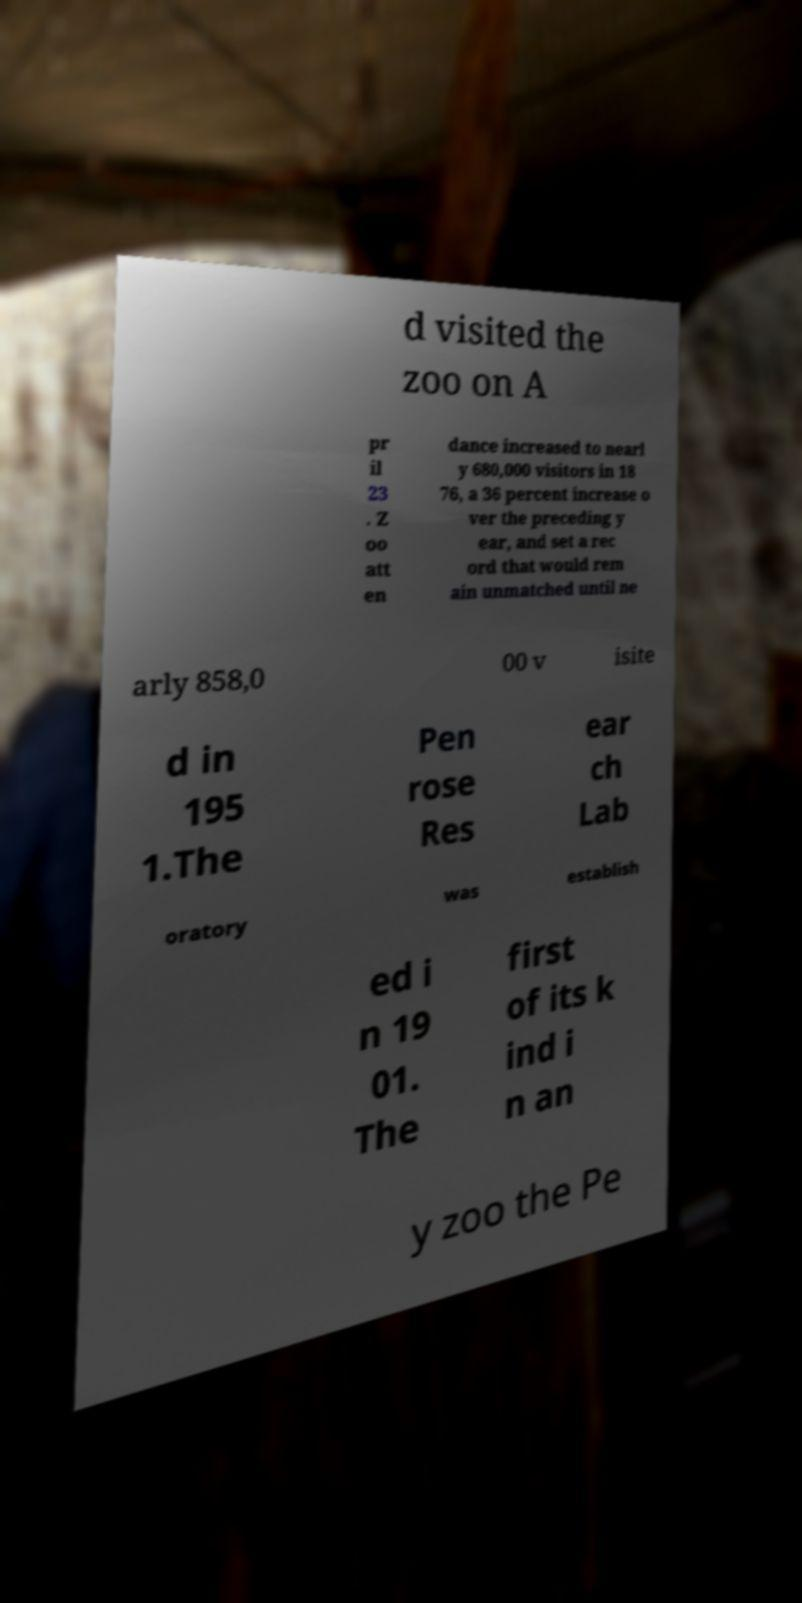I need the written content from this picture converted into text. Can you do that? d visited the zoo on A pr il 23 . Z oo att en dance increased to nearl y 680,000 visitors in 18 76, a 36 percent increase o ver the preceding y ear, and set a rec ord that would rem ain unmatched until ne arly 858,0 00 v isite d in 195 1.The Pen rose Res ear ch Lab oratory was establish ed i n 19 01. The first of its k ind i n an y zoo the Pe 